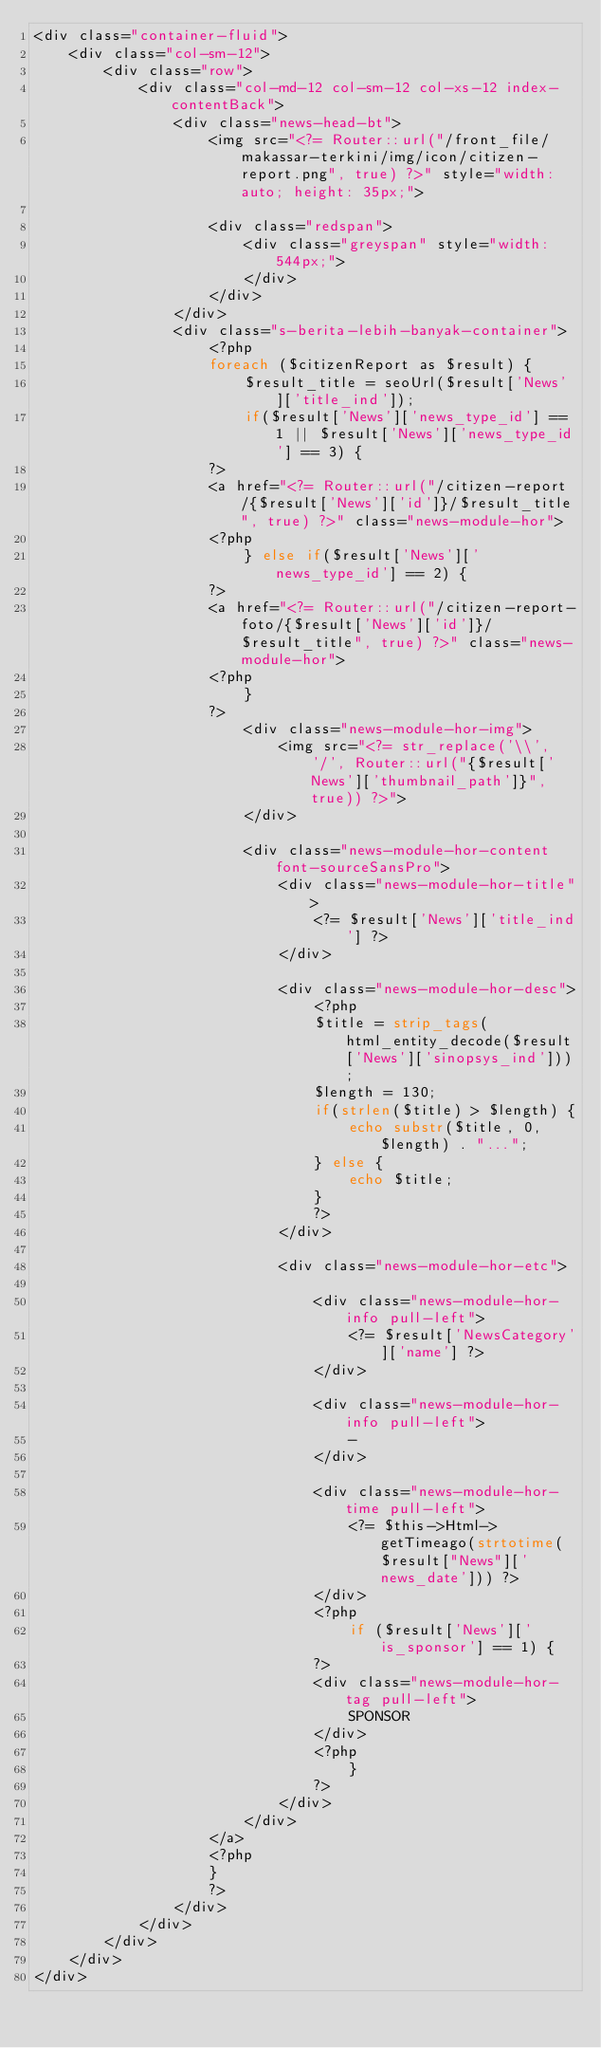<code> <loc_0><loc_0><loc_500><loc_500><_PHP_><div class="container-fluid">
    <div class="col-sm-12">
        <div class="row">
            <div class="col-md-12 col-sm-12 col-xs-12 index-contentBack">
                <div class="news-head-bt">
                    <img src="<?= Router::url("/front_file/makassar-terkini/img/icon/citizen-report.png", true) ?>" style="width: auto; height: 35px;">

                    <div class="redspan">
                        <div class="greyspan" style="width: 544px;">
                        </div>
                    </div>
                </div>
                <div class="s-berita-lebih-banyak-container">
                    <?php
                    foreach ($citizenReport as $result) {
                        $result_title = seoUrl($result['News']['title_ind']);
                        if($result['News']['news_type_id'] == 1 || $result['News']['news_type_id'] == 3) {
                    ?>
                    <a href="<?= Router::url("/citizen-report/{$result['News']['id']}/$result_title", true) ?>" class="news-module-hor">
                    <?php
                        } else if($result['News']['news_type_id'] == 2) {
                    ?>
                    <a href="<?= Router::url("/citizen-report-foto/{$result['News']['id']}/$result_title", true) ?>" class="news-module-hor">
                    <?php
                        }
                    ?>
                        <div class="news-module-hor-img">
                            <img src="<?= str_replace('\\', '/', Router::url("{$result['News']['thumbnail_path']}", true)) ?>">
                        </div>

                        <div class="news-module-hor-content font-sourceSansPro">
                            <div class="news-module-hor-title">
                                <?= $result['News']['title_ind'] ?>
                            </div>

                            <div class="news-module-hor-desc">
                                <?php
                                $title = strip_tags(html_entity_decode($result['News']['sinopsys_ind']));
                                $length = 130;
                                if(strlen($title) > $length) {
                                    echo substr($title, 0, $length) . "...";
                                } else {
                                    echo $title;
                                }
                                ?>
                            </div>

                            <div class="news-module-hor-etc">
                                
                                <div class="news-module-hor-info pull-left">
                                    <?= $result['NewsCategory']['name'] ?>
                                </div>

                                <div class="news-module-hor-info pull-left">
                                    -
                                </div>

                                <div class="news-module-hor-time pull-left">
                                    <?= $this->Html->getTimeago(strtotime($result["News"]['news_date'])) ?>
                                </div>
                                <?php 
                                    if ($result['News']['is_sponsor'] == 1) {
                                ?>
                                <div class="news-module-hor-tag pull-left">
                                    SPONSOR
                                </div>
                                <?php
                                    }
                                ?>
                            </div>
                        </div>
                    </a>
                    <?php
                    }
                    ?>                    
                </div>
            </div>
        </div>
    </div>
</div></code> 